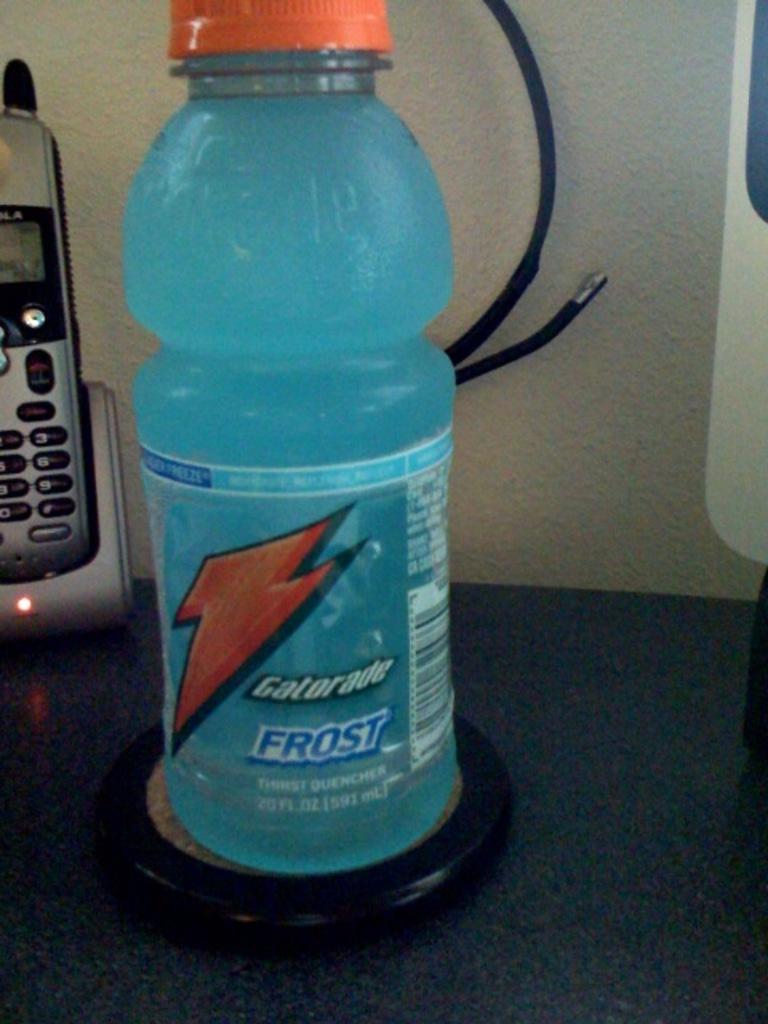What is this device called?
Make the answer very short. Answering does not require reading text in the image. 